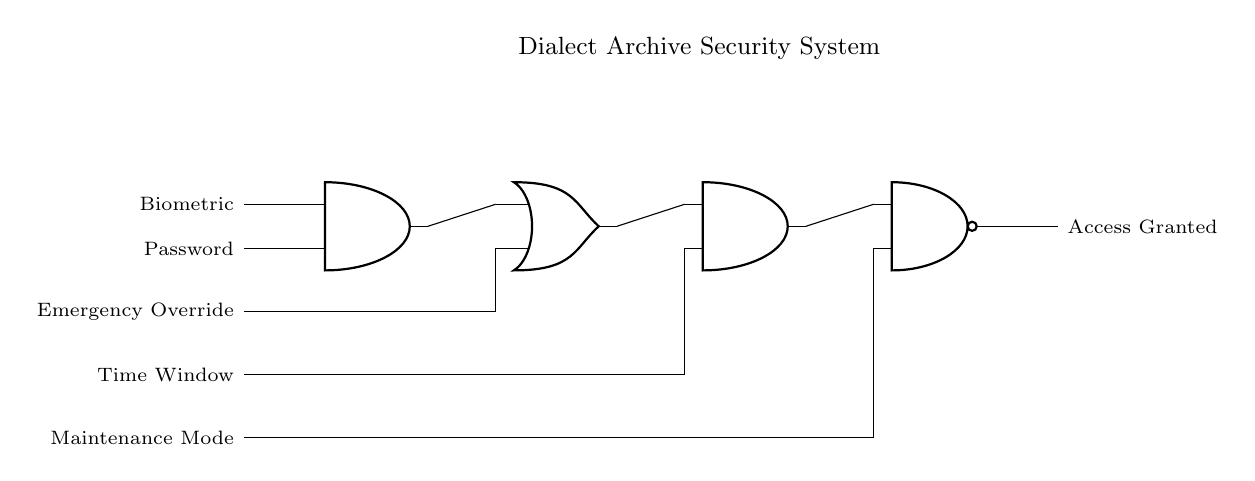What are the inputs of the first AND gate? The first AND gate has two inputs: Biometric and Password. These inputs are necessary for the security system to ensure authentication.
Answer: Biometric, Password What logic gate follows the first AND gate? Following the first AND gate is an OR gate. The output from the AND gate connects to one of the inputs of the OR gate. This setup is used to allow access through multiple conditions.
Answer: OR gate How many total logic gates are present in the circuit? There are four logic gates present in the circuit. They include an AND gate, an OR gate, another AND gate, and a NAND gate, working together to form the security system.
Answer: Four What is the output of the NAND gate? The output of the NAND gate is labeled as Access Granted. This indicates that the system will provide access only when certain conditions are met based on the input logic.
Answer: Access Granted How is the Emergency Override connected in the circuit? The Emergency Override is connected directly to one input of the OR gate. This shows that, irrespective of the biometric and password inputs, activating this override will allow access.
Answer: Directly to OR gate In what situation is Access Granted? Access is granted when any combination of inputs, including the Emergency Override, Time Window, or a valid combination of Biometric and Password, fulfills the conditions set by the AND and OR gates.
Answer: Valid input conditions 